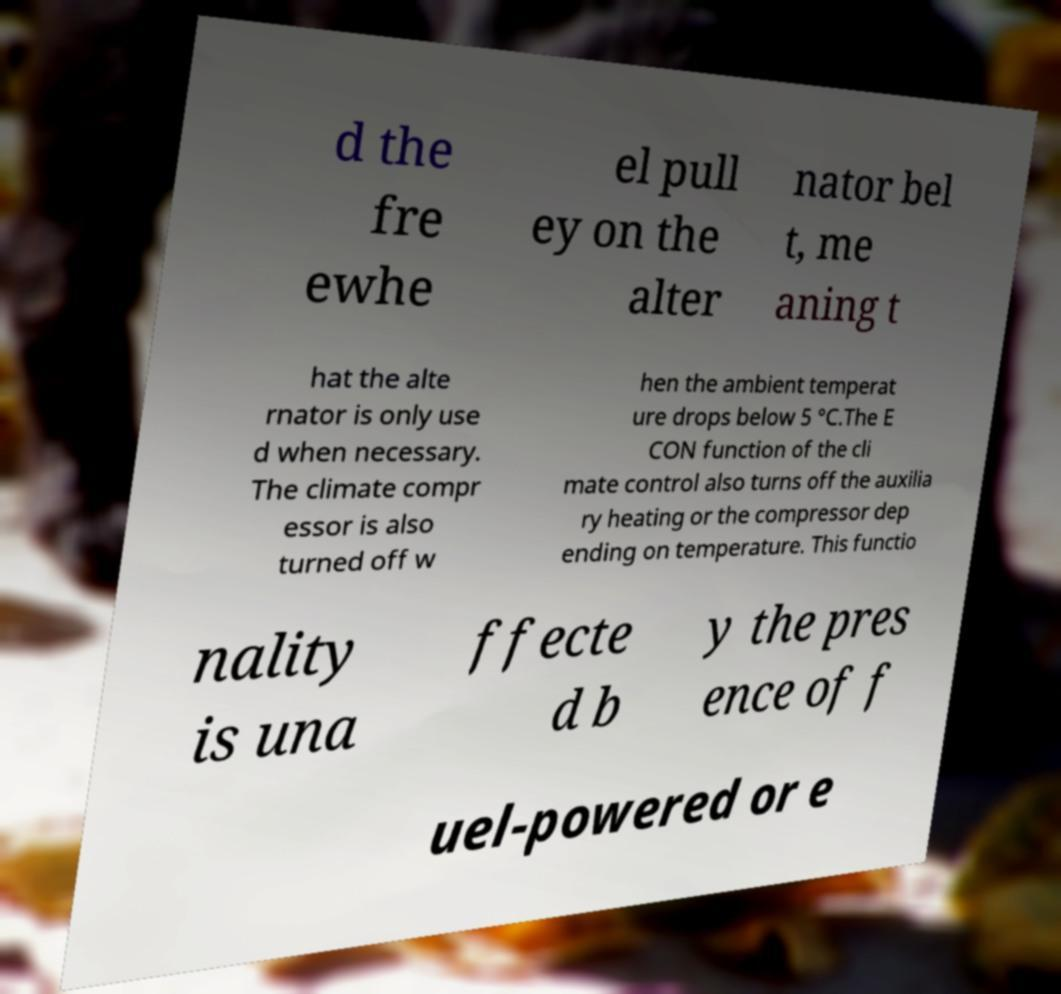Could you assist in decoding the text presented in this image and type it out clearly? d the fre ewhe el pull ey on the alter nator bel t, me aning t hat the alte rnator is only use d when necessary. The climate compr essor is also turned off w hen the ambient temperat ure drops below 5 °C.The E CON function of the cli mate control also turns off the auxilia ry heating or the compressor dep ending on temperature. This functio nality is una ffecte d b y the pres ence of f uel-powered or e 